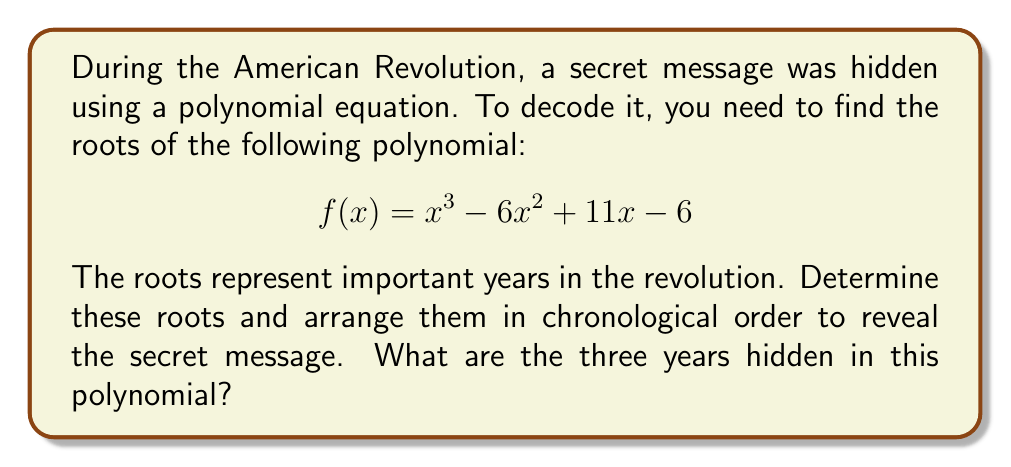Provide a solution to this math problem. To find the roots of the polynomial $f(x) = x^3 - 6x^2 + 11x - 6$, we'll use the following steps:

1) First, let's try to factor out any common factors. In this case, there are none.

2) Next, we can use the rational root theorem. The possible rational roots are the factors of the constant term (6): ±1, ±2, ±3, ±6.

3) Let's test these values:
   $f(1) = 1 - 6 + 11 - 6 = 0$
   We've found our first root: $x = 1$

4) Now we can factor out $(x-1)$:
   $f(x) = (x-1)(x^2 - 5x + 6)$

5) We can solve the quadratic equation $x^2 - 5x + 6 = 0$ using the quadratic formula:
   $x = \frac{-b \pm \sqrt{b^2 - 4ac}}{2a}$

   Here, $a=1$, $b=-5$, and $c=6$

   $x = \frac{5 \pm \sqrt{25 - 24}}{2} = \frac{5 \pm 1}{2}$

6) This gives us our other two roots:
   $x = 3$ and $x = 2$

7) Therefore, the roots are 1, 2, and 3.

8) In chronological order, these represent the years 1773, 1774, and 1775.

These years correspond to significant events in the American Revolution:
1773 - The Boston Tea Party
1774 - The First Continental Congress
1775 - The start of the Revolutionary War
Answer: 1773, 1774, 1775 